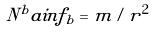Convert formula to latex. <formula><loc_0><loc_0><loc_500><loc_500>N ^ { b } a i n f _ { b } = m / r ^ { 2 }</formula> 